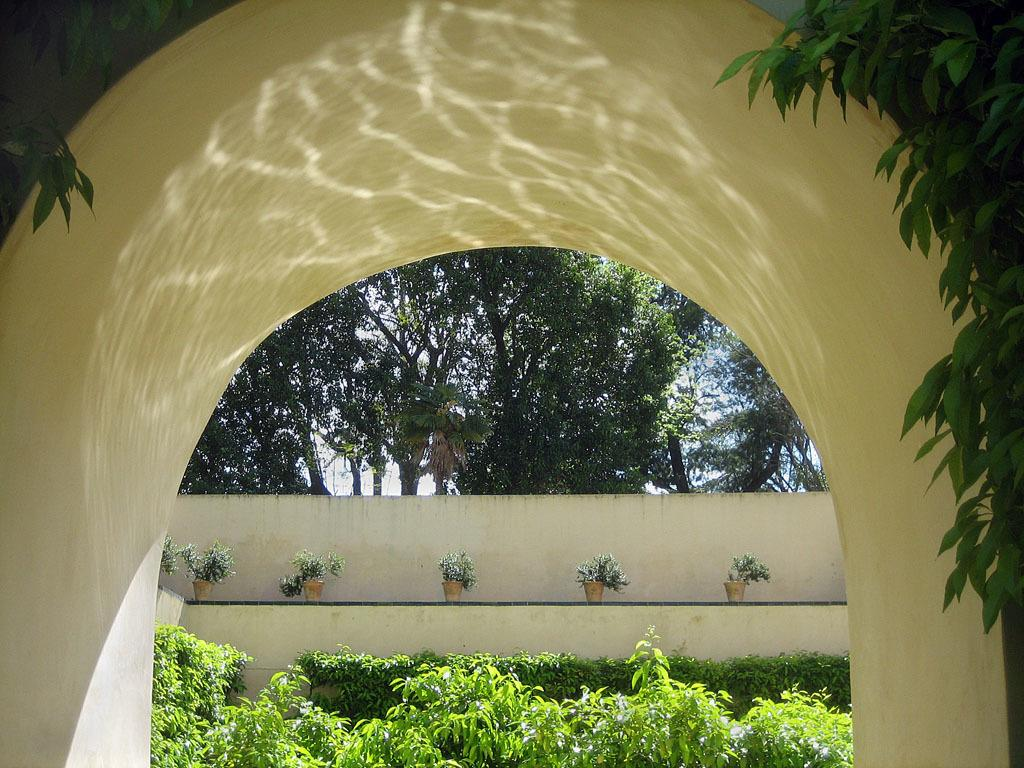What structure is present in the image? There is an arch in the image. What can be seen on the wall in the background of the image? There are plants and pots on the wall in the background. What type of vegetation is at the bottom of the image? There are plants at the bottom of the image. What is visible in the background of the image? The sky is visible in the background of the image. Can you see any blood dripping from the arch in the image? No, there is no blood present in the image. Is there a spark coming from the plants at the bottom of the image? No, there is no spark visible in the image. 